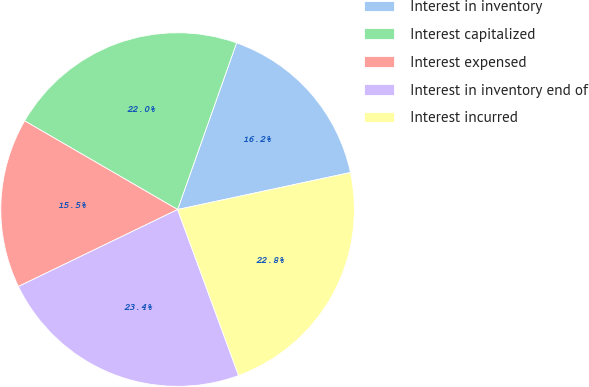Convert chart to OTSL. <chart><loc_0><loc_0><loc_500><loc_500><pie_chart><fcel>Interest in inventory<fcel>Interest capitalized<fcel>Interest expensed<fcel>Interest in inventory end of<fcel>Interest incurred<nl><fcel>16.23%<fcel>22.05%<fcel>15.53%<fcel>23.44%<fcel>22.75%<nl></chart> 